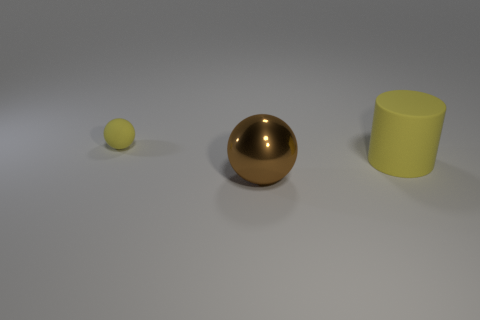Add 1 yellow cylinders. How many objects exist? 4 Subtract 0 red spheres. How many objects are left? 3 Subtract all balls. How many objects are left? 1 Subtract all big purple metal cylinders. Subtract all tiny spheres. How many objects are left? 2 Add 3 big yellow rubber things. How many big yellow rubber things are left? 4 Add 3 brown metallic spheres. How many brown metallic spheres exist? 4 